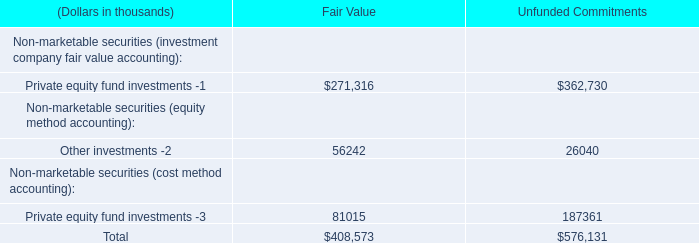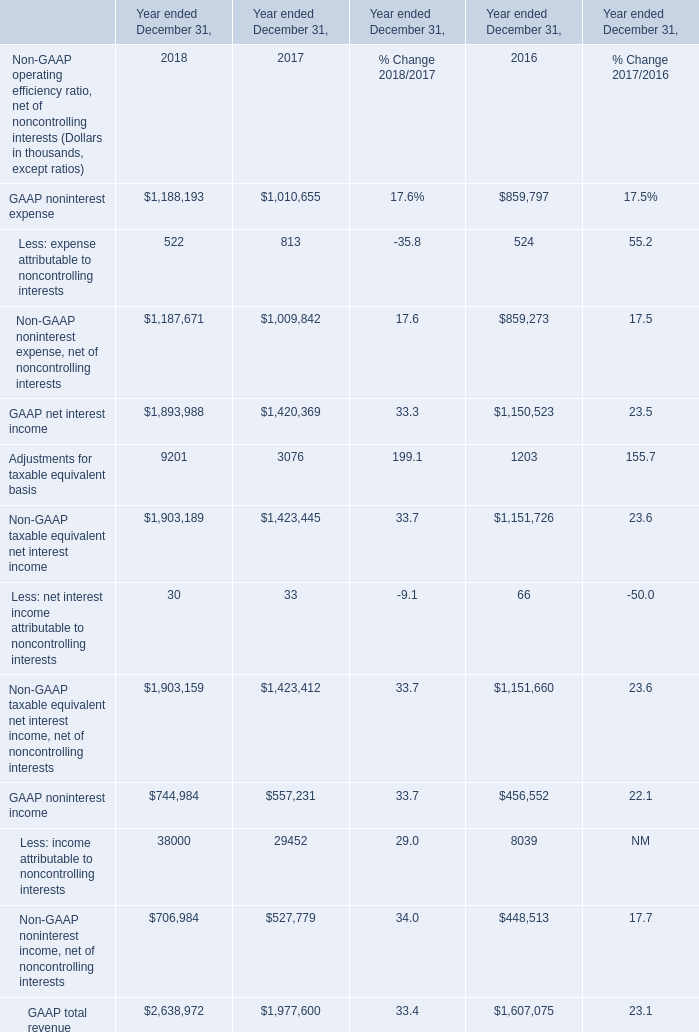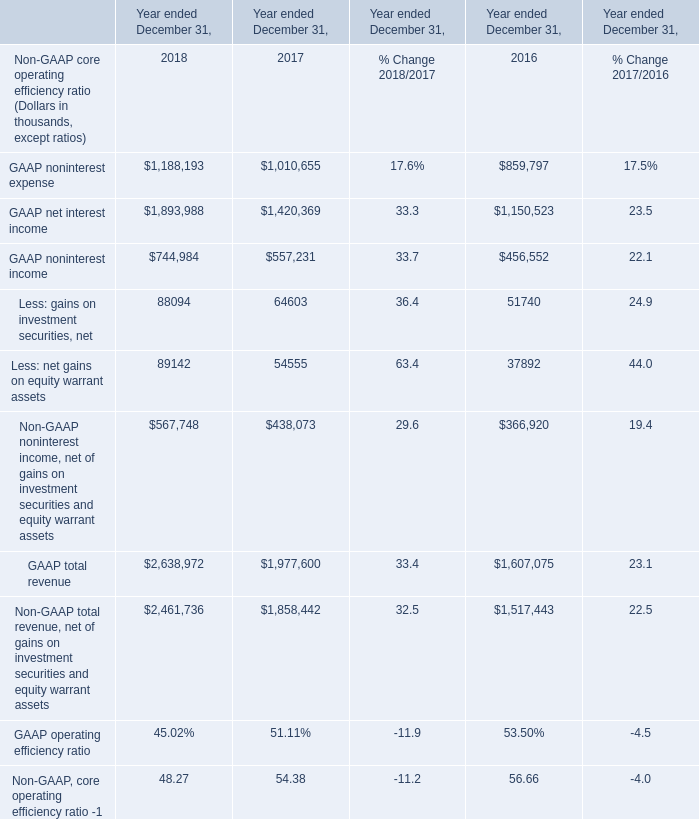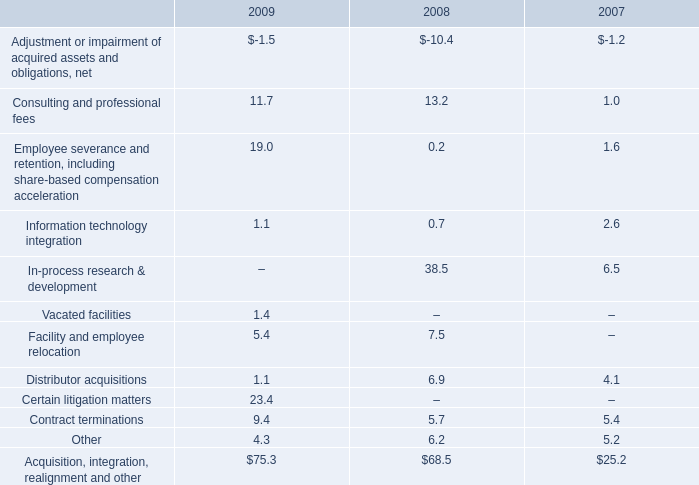What's the sum of GAAP noninterest income of Year ended December 31, 2016, and GAAP noninterest expense of Year ended December 31, 2016 ? 
Computations: (456552.0 + 859797.0)
Answer: 1316349.0. 